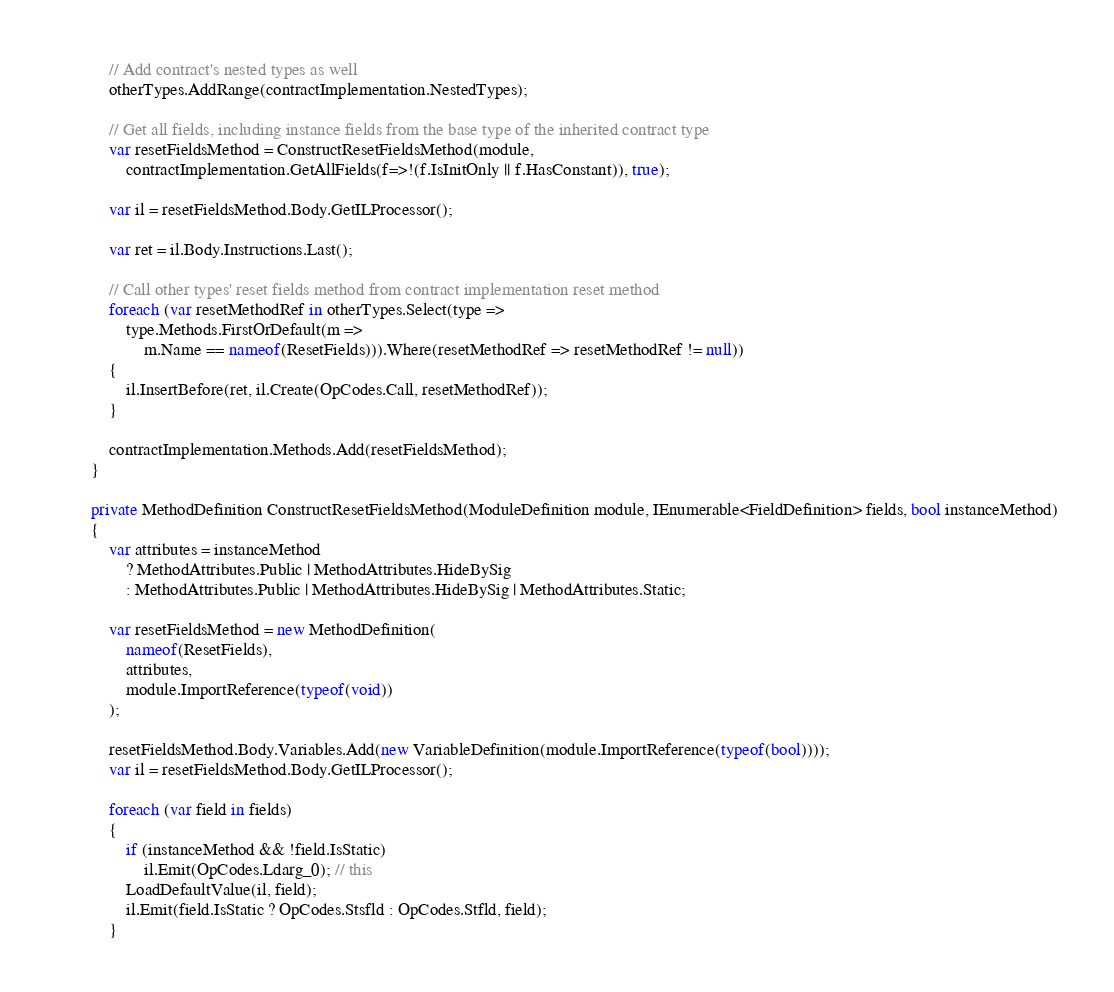Convert code to text. <code><loc_0><loc_0><loc_500><loc_500><_C#_>            // Add contract's nested types as well
            otherTypes.AddRange(contractImplementation.NestedTypes);
            
            // Get all fields, including instance fields from the base type of the inherited contract type
            var resetFieldsMethod = ConstructResetFieldsMethod(module, 
                contractImplementation.GetAllFields(f=>!(f.IsInitOnly || f.HasConstant)), true);

            var il = resetFieldsMethod.Body.GetILProcessor();

            var ret = il.Body.Instructions.Last();

            // Call other types' reset fields method from contract implementation reset method
            foreach (var resetMethodRef in otherTypes.Select(type => 
                type.Methods.FirstOrDefault(m => 
                    m.Name == nameof(ResetFields))).Where(resetMethodRef => resetMethodRef != null))
            {
                il.InsertBefore(ret, il.Create(OpCodes.Call, resetMethodRef));
            }
            
            contractImplementation.Methods.Add(resetFieldsMethod);
        }

        private MethodDefinition ConstructResetFieldsMethod(ModuleDefinition module, IEnumerable<FieldDefinition> fields, bool instanceMethod)
        {
            var attributes = instanceMethod
                ? MethodAttributes.Public | MethodAttributes.HideBySig
                : MethodAttributes.Public | MethodAttributes.HideBySig | MethodAttributes.Static;
            
            var resetFieldsMethod = new MethodDefinition(
                nameof(ResetFields), 
                attributes, 
                module.ImportReference(typeof(void))
            );
            
            resetFieldsMethod.Body.Variables.Add(new VariableDefinition(module.ImportReference(typeof(bool))));
            var il = resetFieldsMethod.Body.GetILProcessor();

            foreach (var field in fields)
            {
                if (instanceMethod && !field.IsStatic)
                    il.Emit(OpCodes.Ldarg_0); // this
                LoadDefaultValue(il, field);
                il.Emit(field.IsStatic ? OpCodes.Stsfld : OpCodes.Stfld, field);
            }
</code> 